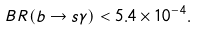Convert formula to latex. <formula><loc_0><loc_0><loc_500><loc_500>B R ( b \to s \gamma ) < 5 . 4 \times 1 0 ^ { - 4 } .</formula> 